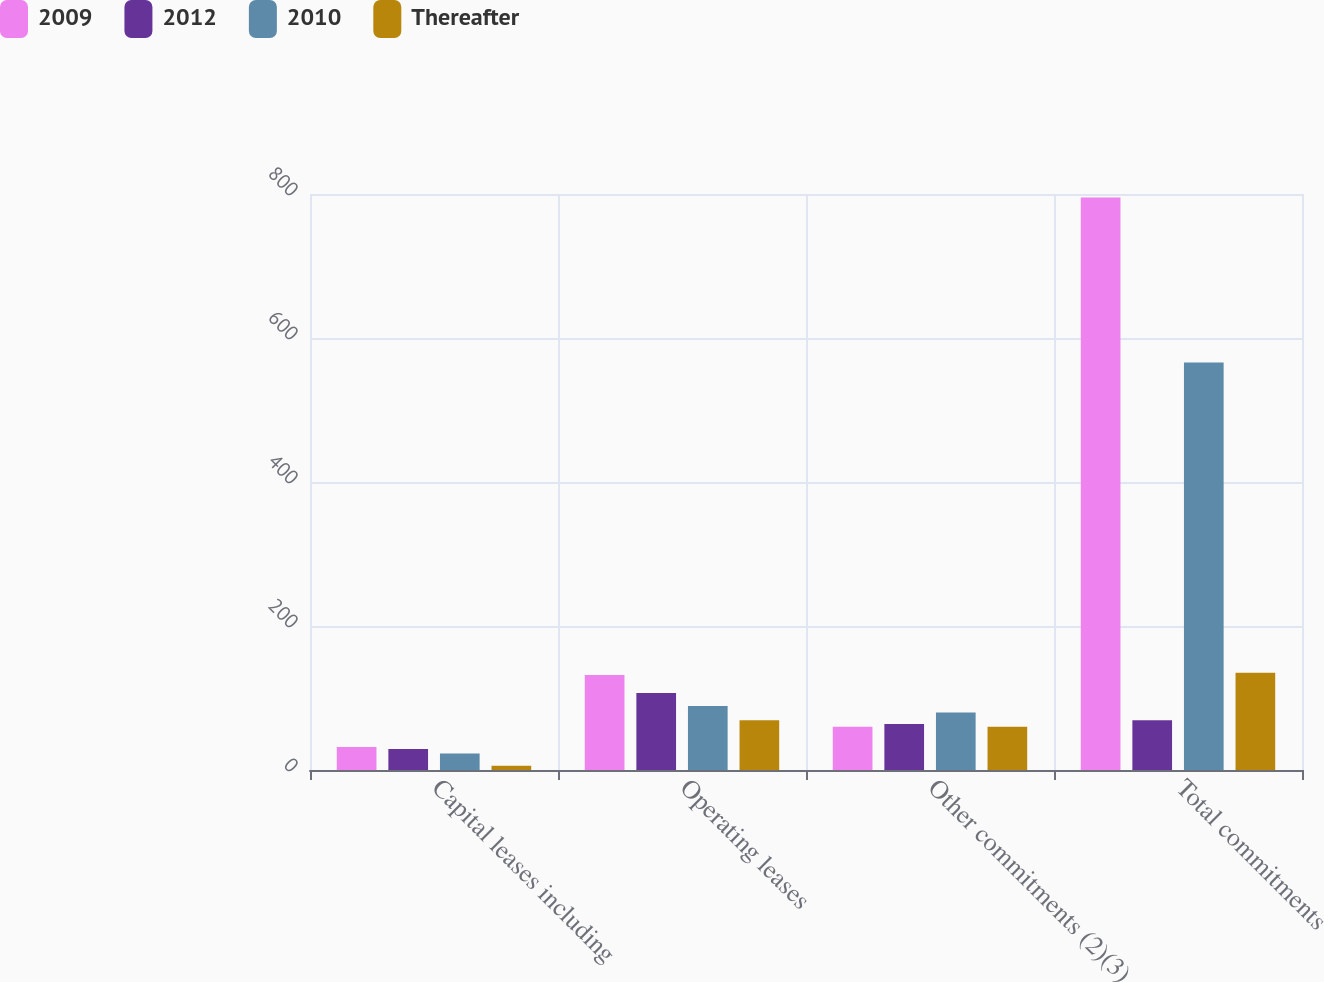<chart> <loc_0><loc_0><loc_500><loc_500><stacked_bar_chart><ecel><fcel>Capital leases including<fcel>Operating leases<fcel>Other commitments (2)(3)<fcel>Total commitments<nl><fcel>2009<fcel>32<fcel>132<fcel>60<fcel>795<nl><fcel>2012<fcel>29<fcel>107<fcel>64<fcel>69<nl><fcel>2010<fcel>23<fcel>89<fcel>80<fcel>566<nl><fcel>Thereafter<fcel>6<fcel>69<fcel>60<fcel>135<nl></chart> 